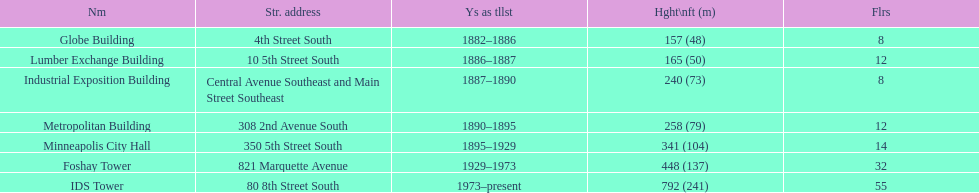How many buildings on the list are taller than 200 feet? 5. 